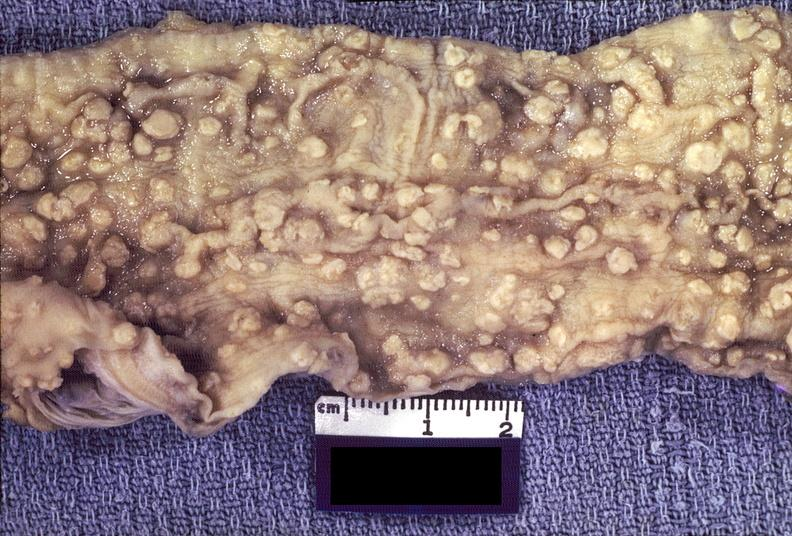what is present?
Answer the question using a single word or phrase. Gastrointestinal 